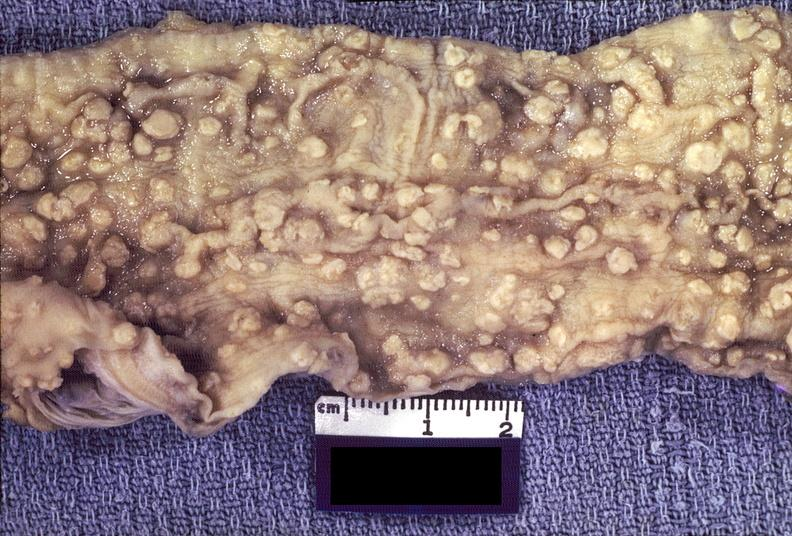what is present?
Answer the question using a single word or phrase. Gastrointestinal 